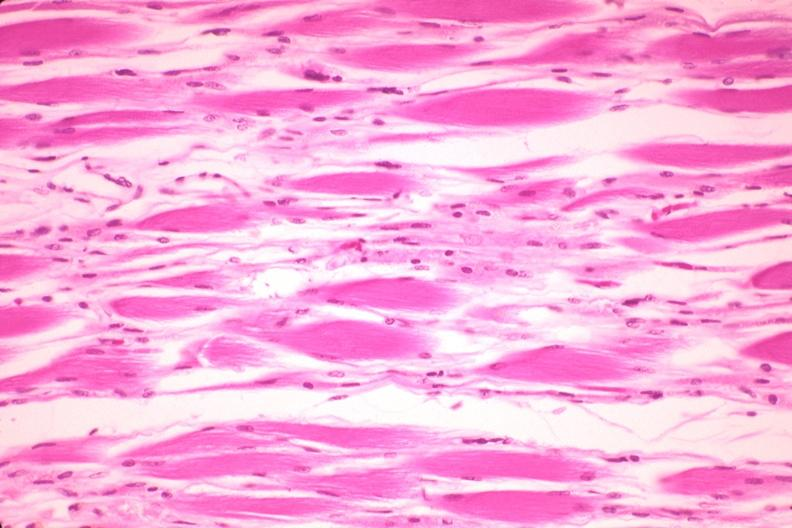what is present?
Answer the question using a single word or phrase. Soft tissue 